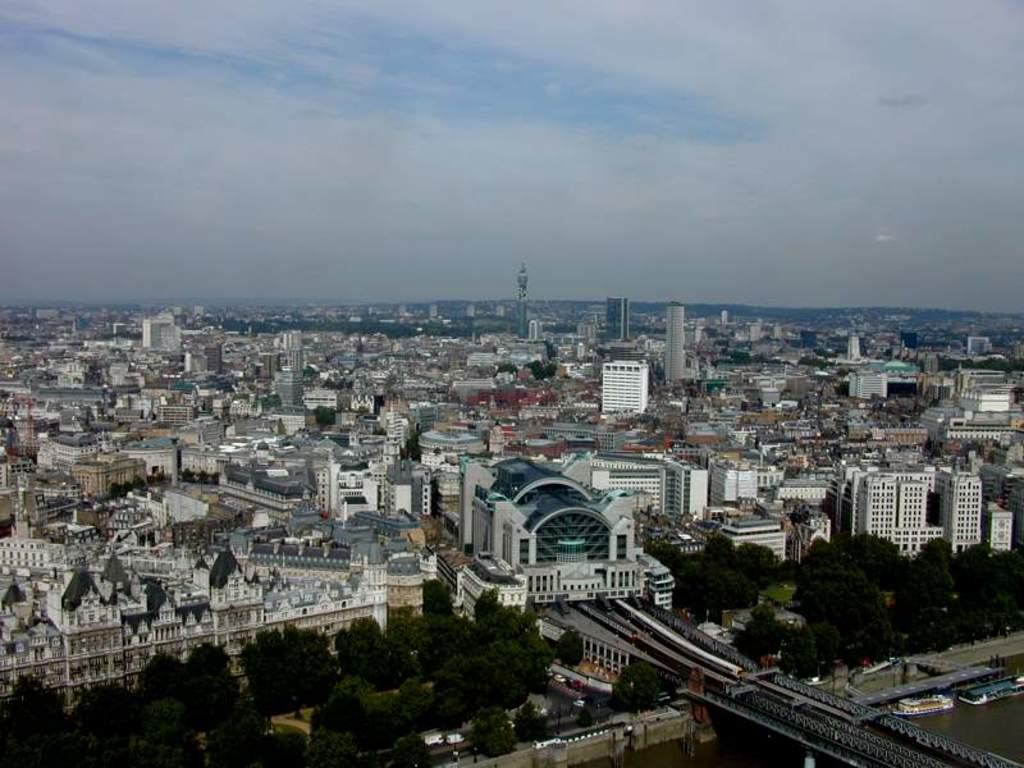What type of structures can be seen in the image? There are buildings in the image. What natural elements are present in the image? There are trees in the image. What man-made feature connects two areas in the image? There is a bridge in the image. What type of transportation is visible in the image? There are boats and vehicles in the image. What is visible in the background of the image? The sky is visible in the background of the image. What can be observed in the sky? There are clouds in the sky. Where is the scarecrow located in the image? There is no scarecrow present in the image. What color is the vein running through the parcel in the image? There is no parcel or vein present in the image. 